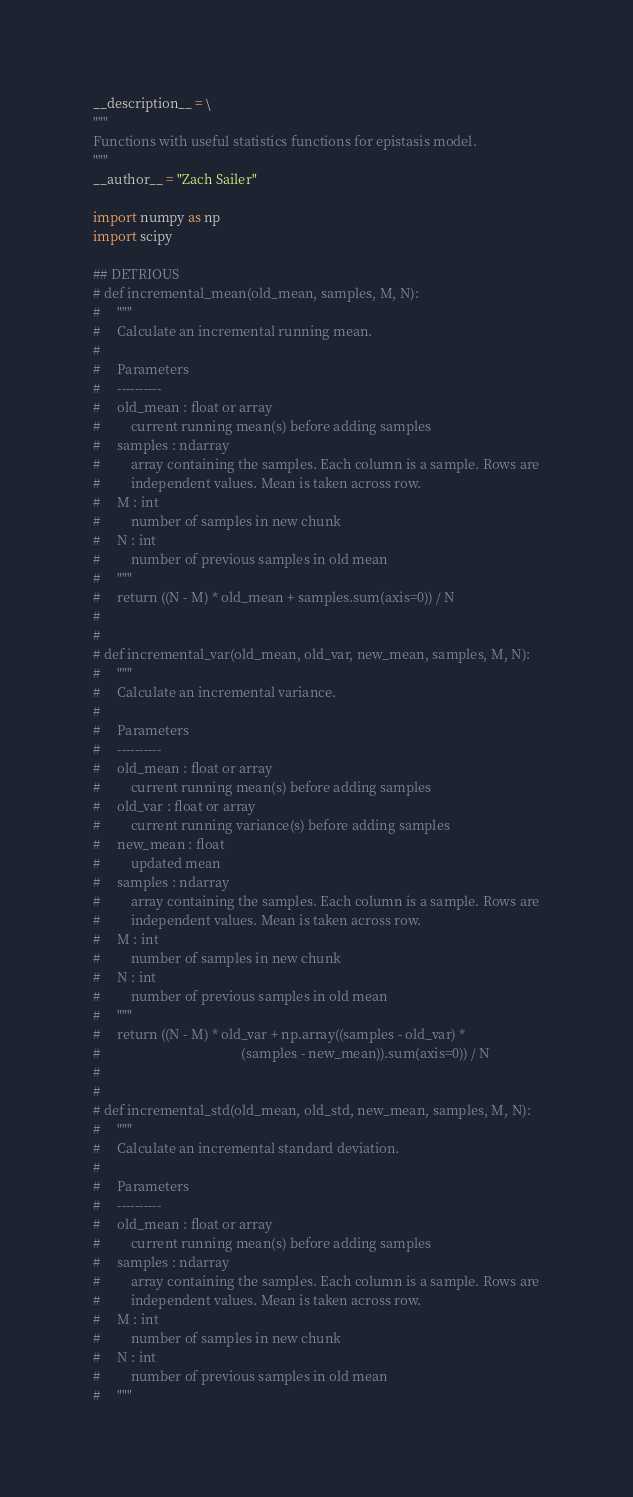Convert code to text. <code><loc_0><loc_0><loc_500><loc_500><_Python_>__description__ = \
"""
Functions with useful statistics functions for epistasis model.
"""
__author__ = "Zach Sailer"

import numpy as np
import scipy

## DETRIOUS
# def incremental_mean(old_mean, samples, M, N):
#     """
#     Calculate an incremental running mean.
#
#     Parameters
#     ----------
#     old_mean : float or array
#         current running mean(s) before adding samples
#     samples : ndarray
#         array containing the samples. Each column is a sample. Rows are
#         independent values. Mean is taken across row.
#     M : int
#         number of samples in new chunk
#     N : int
#         number of previous samples in old mean
#     """
#     return ((N - M) * old_mean + samples.sum(axis=0)) / N
#
#
# def incremental_var(old_mean, old_var, new_mean, samples, M, N):
#     """
#     Calculate an incremental variance.
#
#     Parameters
#     ----------
#     old_mean : float or array
#         current running mean(s) before adding samples
#     old_var : float or array
#         current running variance(s) before adding samples
#     new_mean : float
#         updated mean
#     samples : ndarray
#         array containing the samples. Each column is a sample. Rows are
#         independent values. Mean is taken across row.
#     M : int
#         number of samples in new chunk
#     N : int
#         number of previous samples in old mean
#     """
#     return ((N - M) * old_var + np.array((samples - old_var) *
#                                          (samples - new_mean)).sum(axis=0)) / N
#
#
# def incremental_std(old_mean, old_std, new_mean, samples, M, N):
#     """
#     Calculate an incremental standard deviation.
#
#     Parameters
#     ----------
#     old_mean : float or array
#         current running mean(s) before adding samples
#     samples : ndarray
#         array containing the samples. Each column is a sample. Rows are
#         independent values. Mean is taken across row.
#     M : int
#         number of samples in new chunk
#     N : int
#         number of previous samples in old mean
#     """</code> 